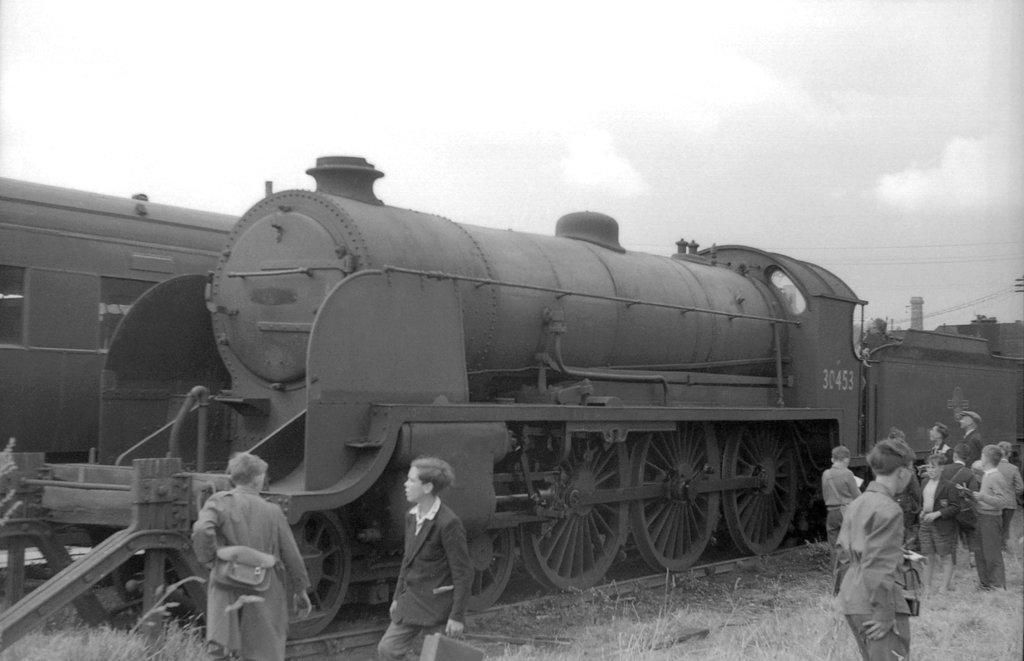Describe this image in one or two sentences. It is a black and white image. In the center of the image there is a train engine on the railway track. Beside the engine there are people standing on the grass. In the background of the image there is sky. 